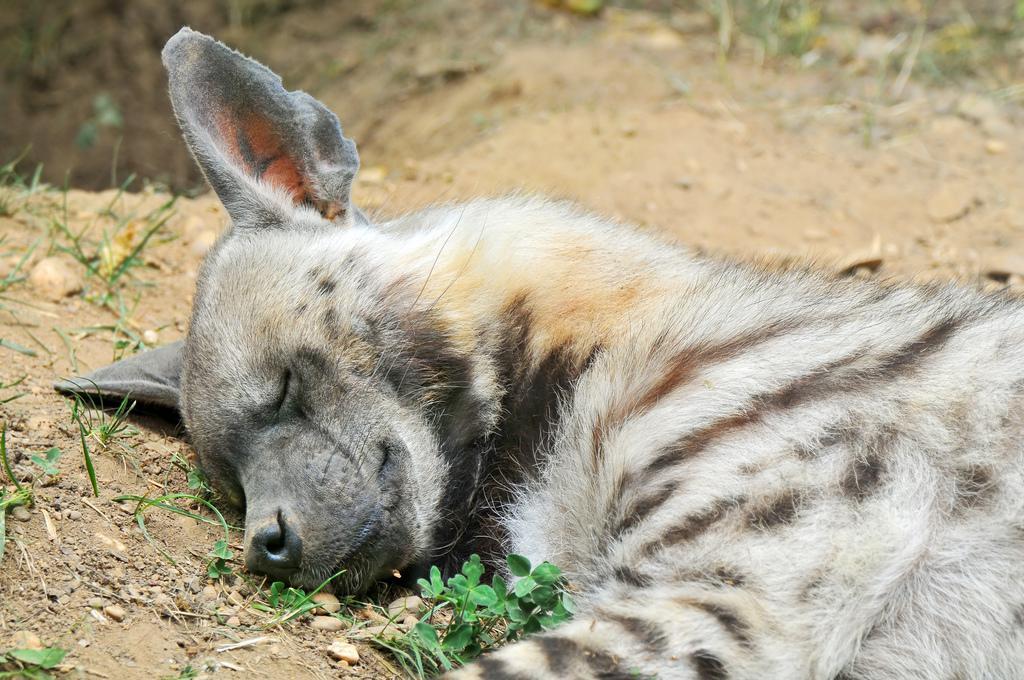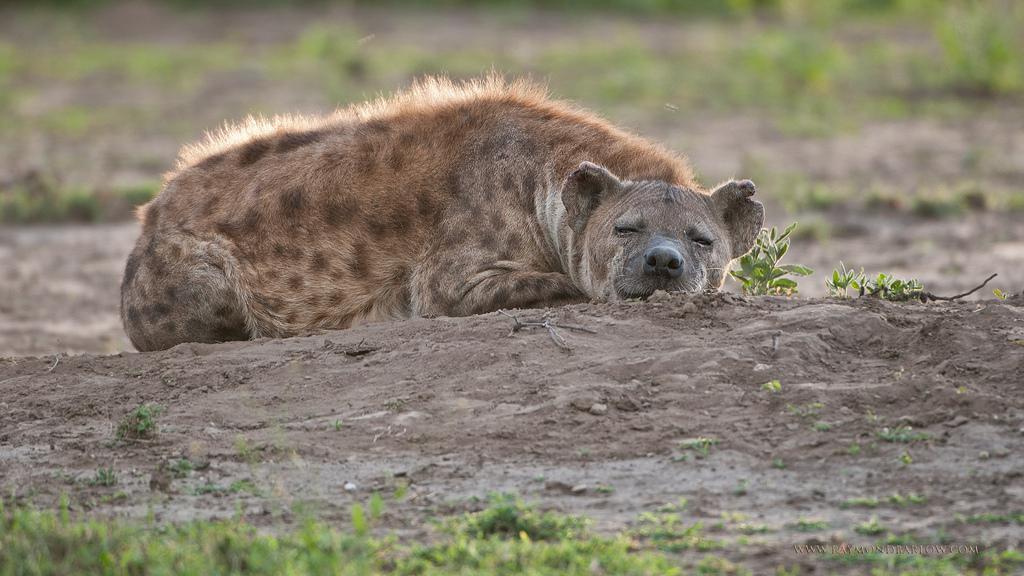The first image is the image on the left, the second image is the image on the right. For the images displayed, is the sentence "Each image shows a reclining hyena with its body turned forward, and the right image features a reclining adult hyena with at least one hyena pup draped over it." factually correct? Answer yes or no. No. The first image is the image on the left, the second image is the image on the right. Given the left and right images, does the statement "A hyena is laying on another hyena." hold true? Answer yes or no. No. 